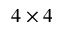Convert formula to latex. <formula><loc_0><loc_0><loc_500><loc_500>4 \times 4</formula> 